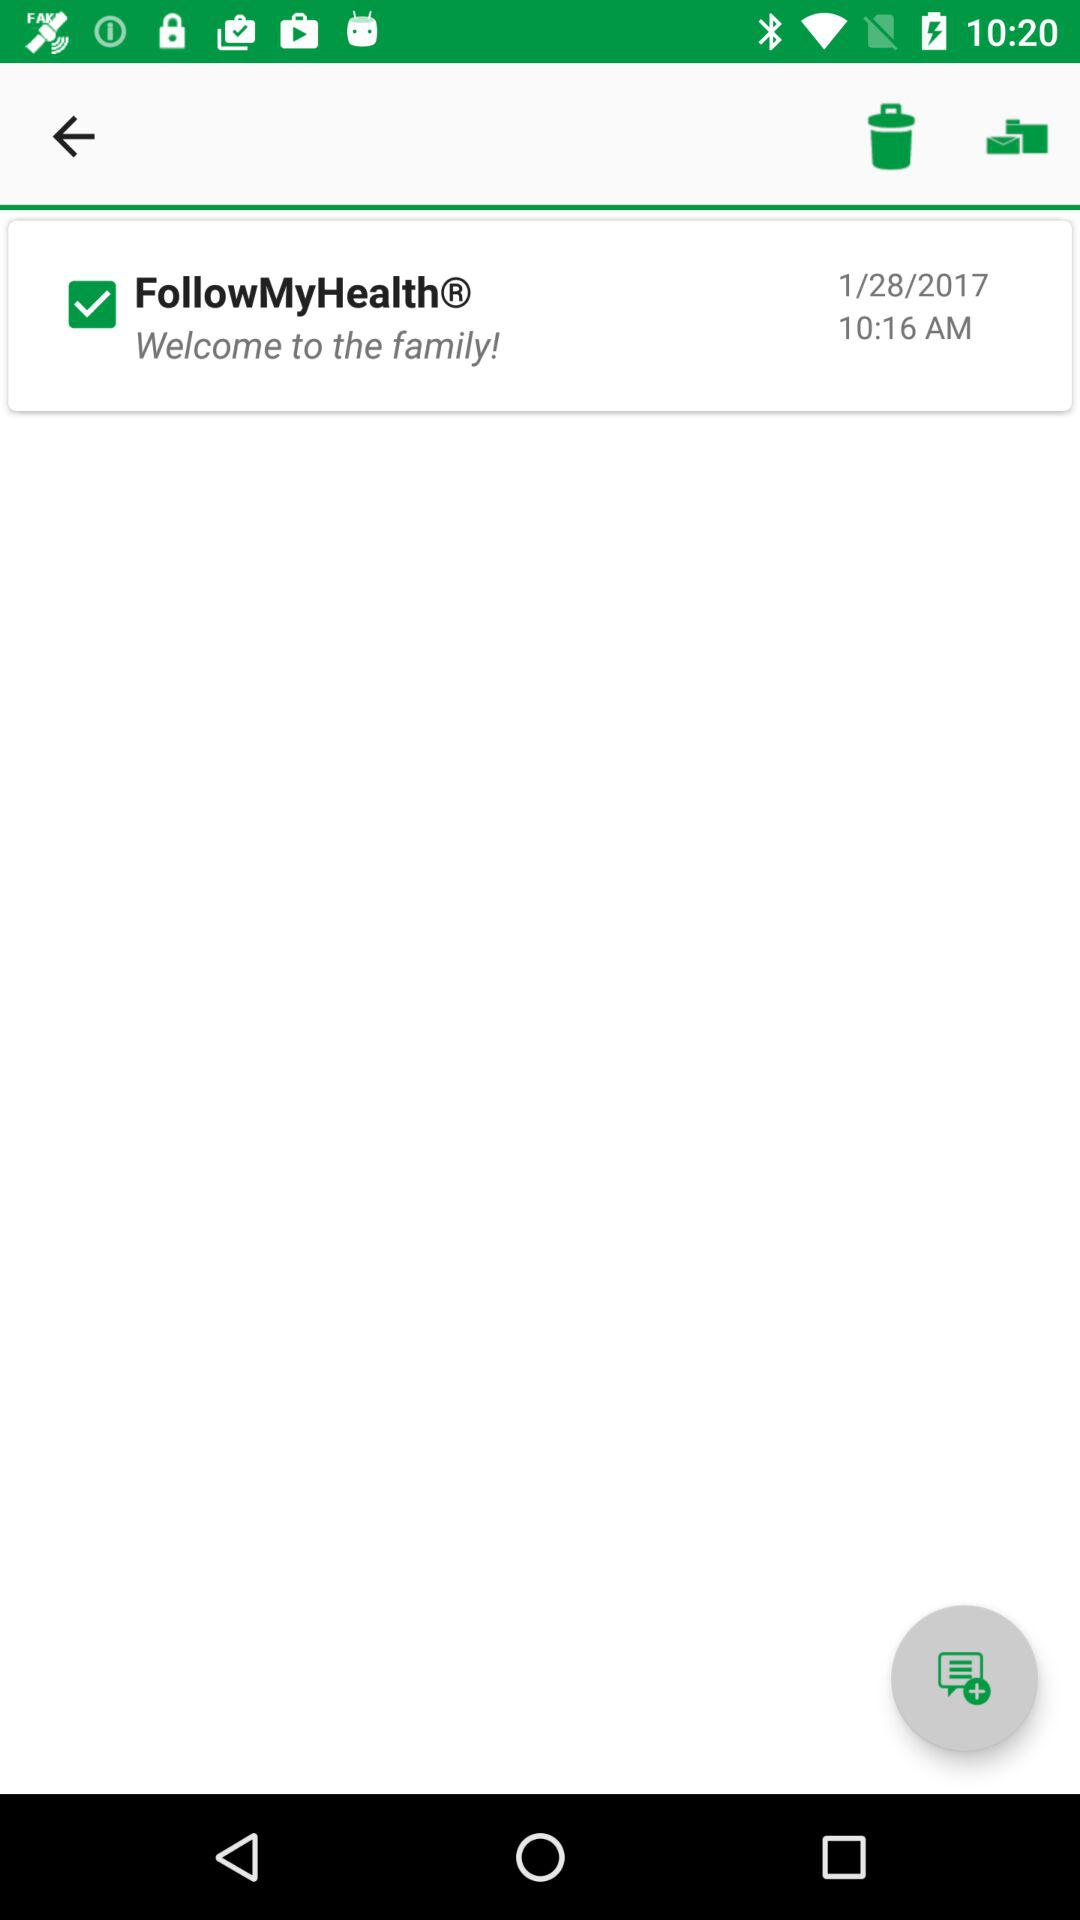What is the time? The time is 10:16 AM. 